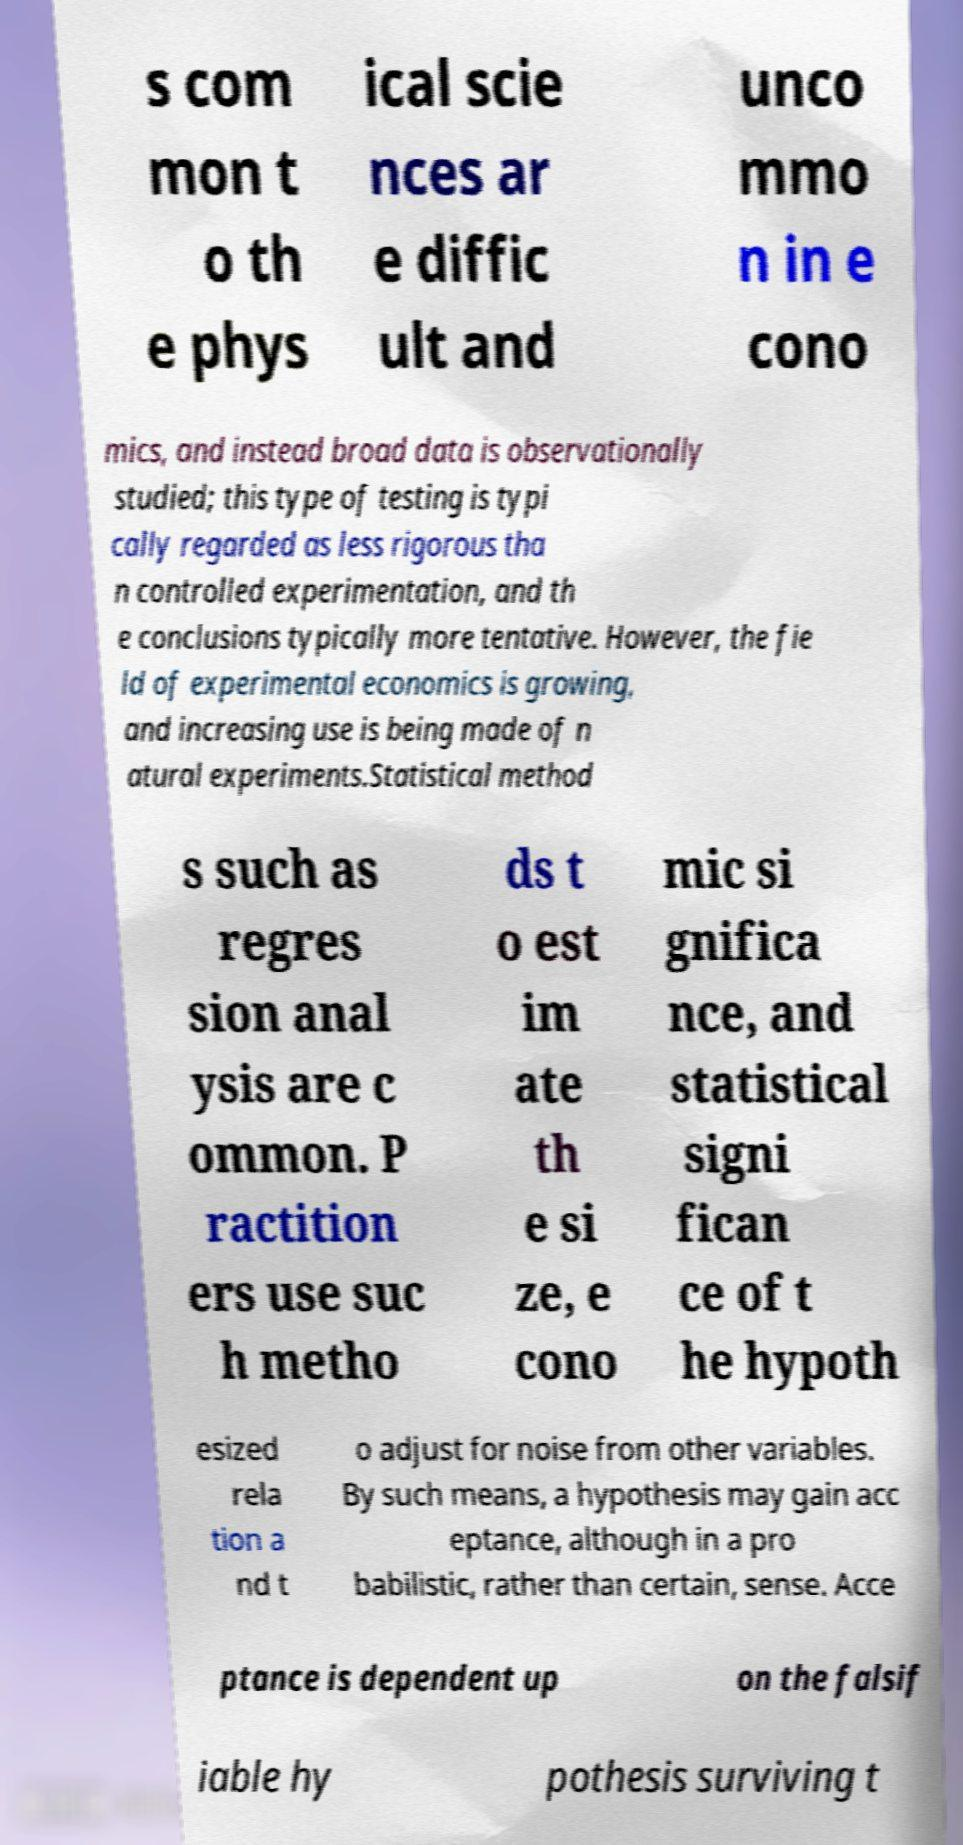Please read and relay the text visible in this image. What does it say? s com mon t o th e phys ical scie nces ar e diffic ult and unco mmo n in e cono mics, and instead broad data is observationally studied; this type of testing is typi cally regarded as less rigorous tha n controlled experimentation, and th e conclusions typically more tentative. However, the fie ld of experimental economics is growing, and increasing use is being made of n atural experiments.Statistical method s such as regres sion anal ysis are c ommon. P ractition ers use suc h metho ds t o est im ate th e si ze, e cono mic si gnifica nce, and statistical signi fican ce of t he hypoth esized rela tion a nd t o adjust for noise from other variables. By such means, a hypothesis may gain acc eptance, although in a pro babilistic, rather than certain, sense. Acce ptance is dependent up on the falsif iable hy pothesis surviving t 